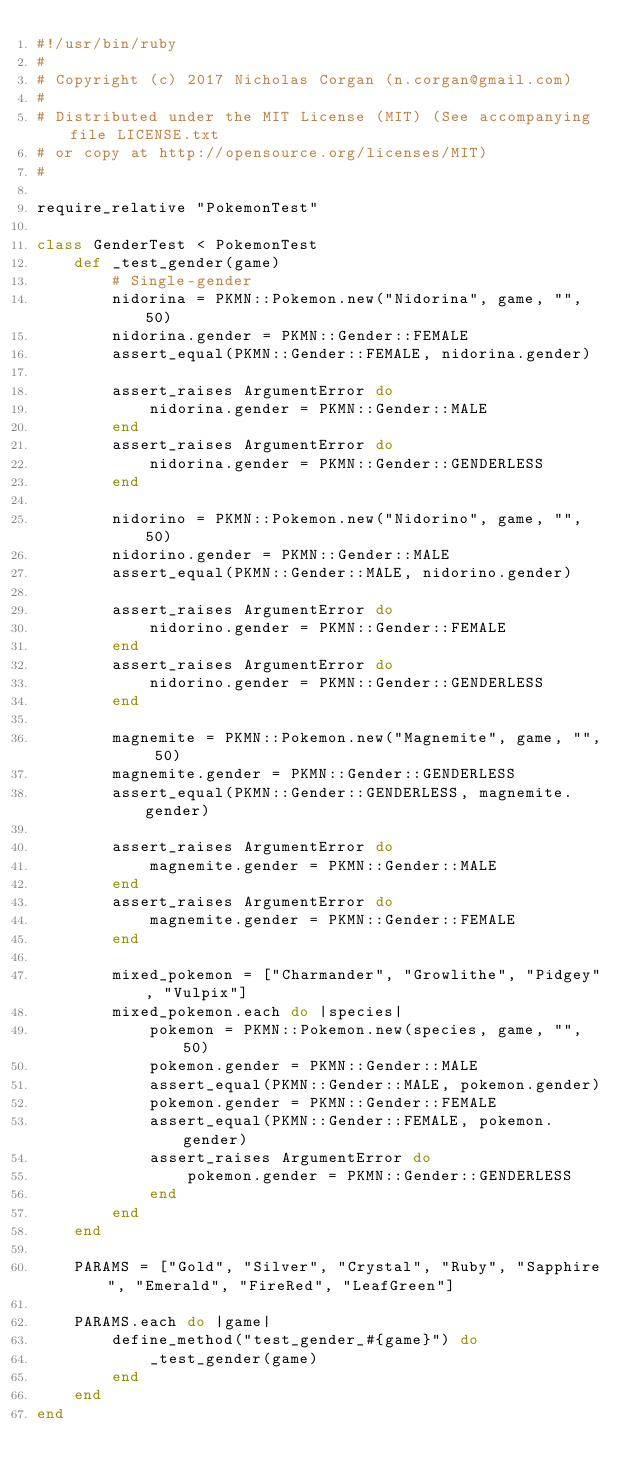<code> <loc_0><loc_0><loc_500><loc_500><_Ruby_>#!/usr/bin/ruby
#
# Copyright (c) 2017 Nicholas Corgan (n.corgan@gmail.com)
#
# Distributed under the MIT License (MIT) (See accompanying file LICENSE.txt
# or copy at http://opensource.org/licenses/MIT)
#

require_relative "PokemonTest"

class GenderTest < PokemonTest
    def _test_gender(game)
        # Single-gender
        nidorina = PKMN::Pokemon.new("Nidorina", game, "", 50)
        nidorina.gender = PKMN::Gender::FEMALE
        assert_equal(PKMN::Gender::FEMALE, nidorina.gender)

        assert_raises ArgumentError do
            nidorina.gender = PKMN::Gender::MALE
        end
        assert_raises ArgumentError do
            nidorina.gender = PKMN::Gender::GENDERLESS
        end

        nidorino = PKMN::Pokemon.new("Nidorino", game, "", 50)
        nidorino.gender = PKMN::Gender::MALE
        assert_equal(PKMN::Gender::MALE, nidorino.gender)

        assert_raises ArgumentError do
            nidorino.gender = PKMN::Gender::FEMALE
        end
        assert_raises ArgumentError do
            nidorino.gender = PKMN::Gender::GENDERLESS
        end

        magnemite = PKMN::Pokemon.new("Magnemite", game, "", 50)
        magnemite.gender = PKMN::Gender::GENDERLESS
        assert_equal(PKMN::Gender::GENDERLESS, magnemite.gender)

        assert_raises ArgumentError do
            magnemite.gender = PKMN::Gender::MALE
        end
        assert_raises ArgumentError do
            magnemite.gender = PKMN::Gender::FEMALE
        end

        mixed_pokemon = ["Charmander", "Growlithe", "Pidgey", "Vulpix"]
        mixed_pokemon.each do |species|
            pokemon = PKMN::Pokemon.new(species, game, "", 50)
            pokemon.gender = PKMN::Gender::MALE
            assert_equal(PKMN::Gender::MALE, pokemon.gender)
            pokemon.gender = PKMN::Gender::FEMALE
            assert_equal(PKMN::Gender::FEMALE, pokemon.gender)
            assert_raises ArgumentError do
                pokemon.gender = PKMN::Gender::GENDERLESS
            end
        end
    end

    PARAMS = ["Gold", "Silver", "Crystal", "Ruby", "Sapphire", "Emerald", "FireRed", "LeafGreen"]

    PARAMS.each do |game|
        define_method("test_gender_#{game}") do
            _test_gender(game)
        end
    end
end
</code> 